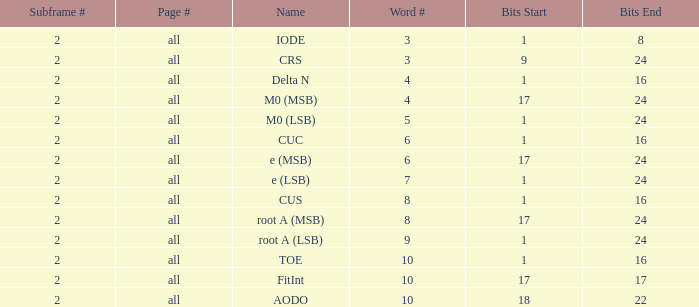What is the average word count with crs and subframes lesser than 2? None. 